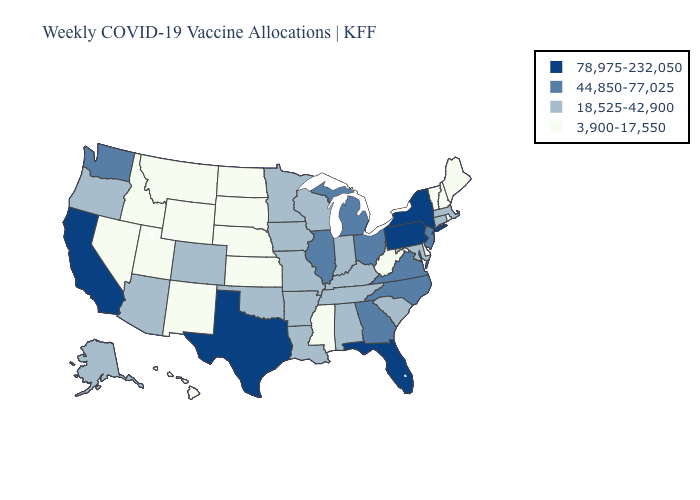Among the states that border Tennessee , which have the lowest value?
Concise answer only. Mississippi. How many symbols are there in the legend?
Quick response, please. 4. Name the states that have a value in the range 44,850-77,025?
Answer briefly. Georgia, Illinois, Michigan, New Jersey, North Carolina, Ohio, Virginia, Washington. What is the highest value in the USA?
Keep it brief. 78,975-232,050. Among the states that border New Hampshire , does Maine have the highest value?
Answer briefly. No. Name the states that have a value in the range 18,525-42,900?
Short answer required. Alabama, Alaska, Arizona, Arkansas, Colorado, Connecticut, Indiana, Iowa, Kentucky, Louisiana, Maryland, Massachusetts, Minnesota, Missouri, Oklahoma, Oregon, South Carolina, Tennessee, Wisconsin. What is the highest value in states that border Michigan?
Keep it brief. 44,850-77,025. What is the highest value in states that border Vermont?
Short answer required. 78,975-232,050. Does Kentucky have a lower value than New Hampshire?
Write a very short answer. No. Does Georgia have the lowest value in the USA?
Concise answer only. No. Name the states that have a value in the range 3,900-17,550?
Be succinct. Delaware, Hawaii, Idaho, Kansas, Maine, Mississippi, Montana, Nebraska, Nevada, New Hampshire, New Mexico, North Dakota, Rhode Island, South Dakota, Utah, Vermont, West Virginia, Wyoming. Which states have the lowest value in the USA?
Write a very short answer. Delaware, Hawaii, Idaho, Kansas, Maine, Mississippi, Montana, Nebraska, Nevada, New Hampshire, New Mexico, North Dakota, Rhode Island, South Dakota, Utah, Vermont, West Virginia, Wyoming. Name the states that have a value in the range 78,975-232,050?
Short answer required. California, Florida, New York, Pennsylvania, Texas. Which states have the highest value in the USA?
Answer briefly. California, Florida, New York, Pennsylvania, Texas. What is the value of New Hampshire?
Short answer required. 3,900-17,550. 